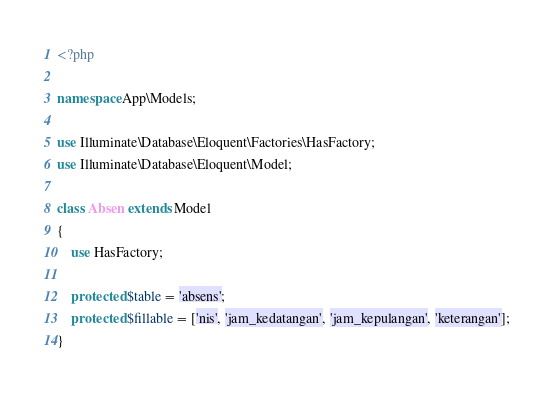Convert code to text. <code><loc_0><loc_0><loc_500><loc_500><_PHP_><?php

namespace App\Models;

use Illuminate\Database\Eloquent\Factories\HasFactory;
use Illuminate\Database\Eloquent\Model;

class Absen extends Model
{
    use HasFactory;

    protected $table = 'absens';
    protected $fillable = ['nis', 'jam_kedatangan', 'jam_kepulangan', 'keterangan'];
}
</code> 